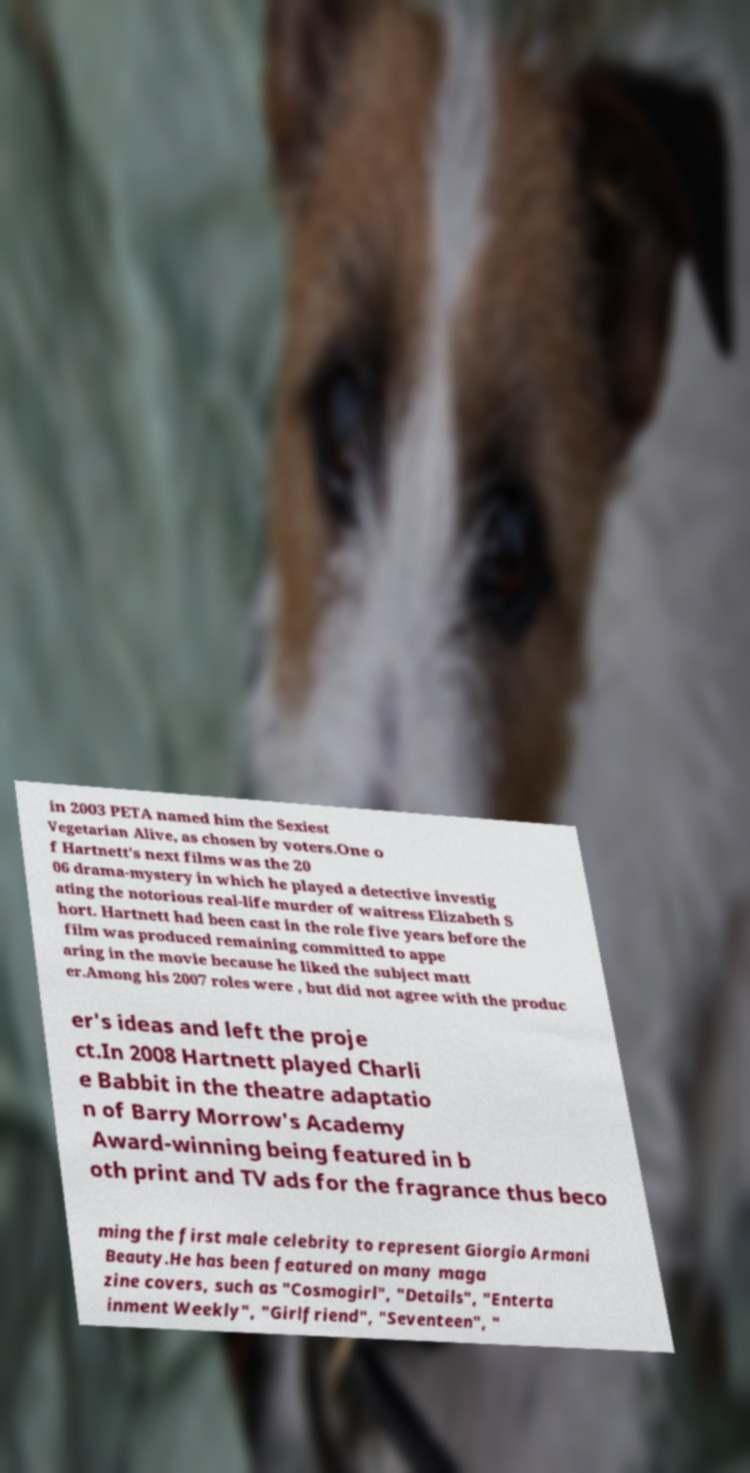What messages or text are displayed in this image? I need them in a readable, typed format. in 2003 PETA named him the Sexiest Vegetarian Alive, as chosen by voters.One o f Hartnett's next films was the 20 06 drama-mystery in which he played a detective investig ating the notorious real-life murder of waitress Elizabeth S hort. Hartnett had been cast in the role five years before the film was produced remaining committed to appe aring in the movie because he liked the subject matt er.Among his 2007 roles were , but did not agree with the produc er's ideas and left the proje ct.In 2008 Hartnett played Charli e Babbit in the theatre adaptatio n of Barry Morrow's Academy Award-winning being featured in b oth print and TV ads for the fragrance thus beco ming the first male celebrity to represent Giorgio Armani Beauty.He has been featured on many maga zine covers, such as "Cosmogirl", "Details", "Enterta inment Weekly", "Girlfriend", "Seventeen", " 